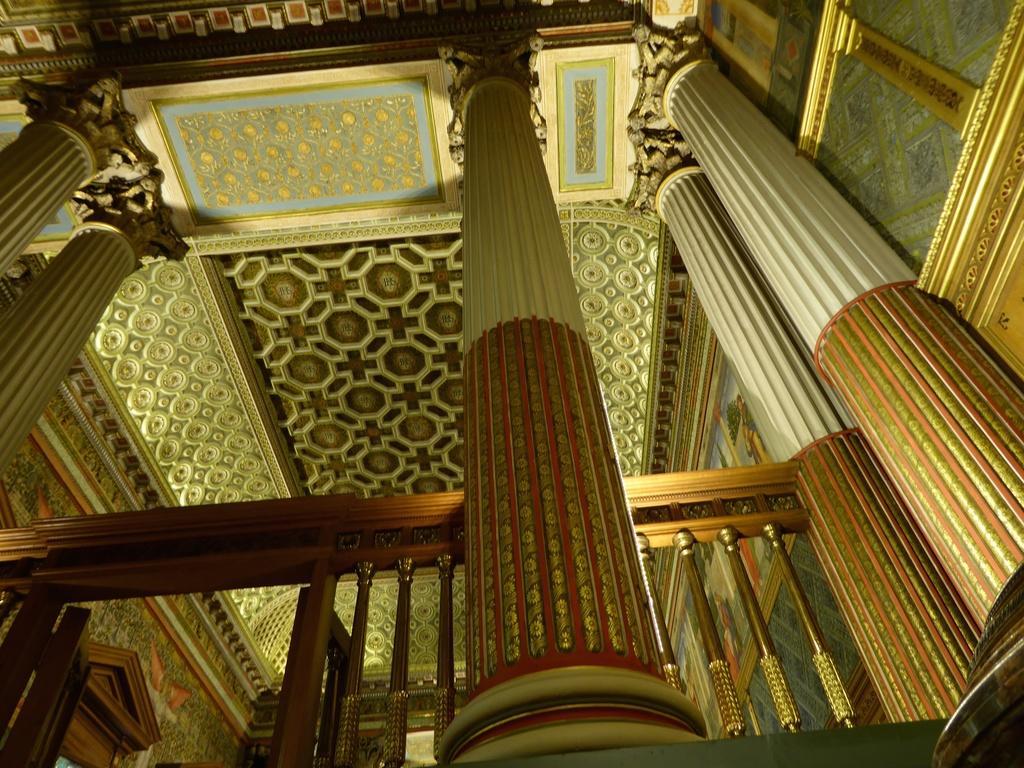Can you describe this image briefly? In this picture, we see the pillars and the railing. At the top, we see the roof of the building. This picture is clicked inside the building. 